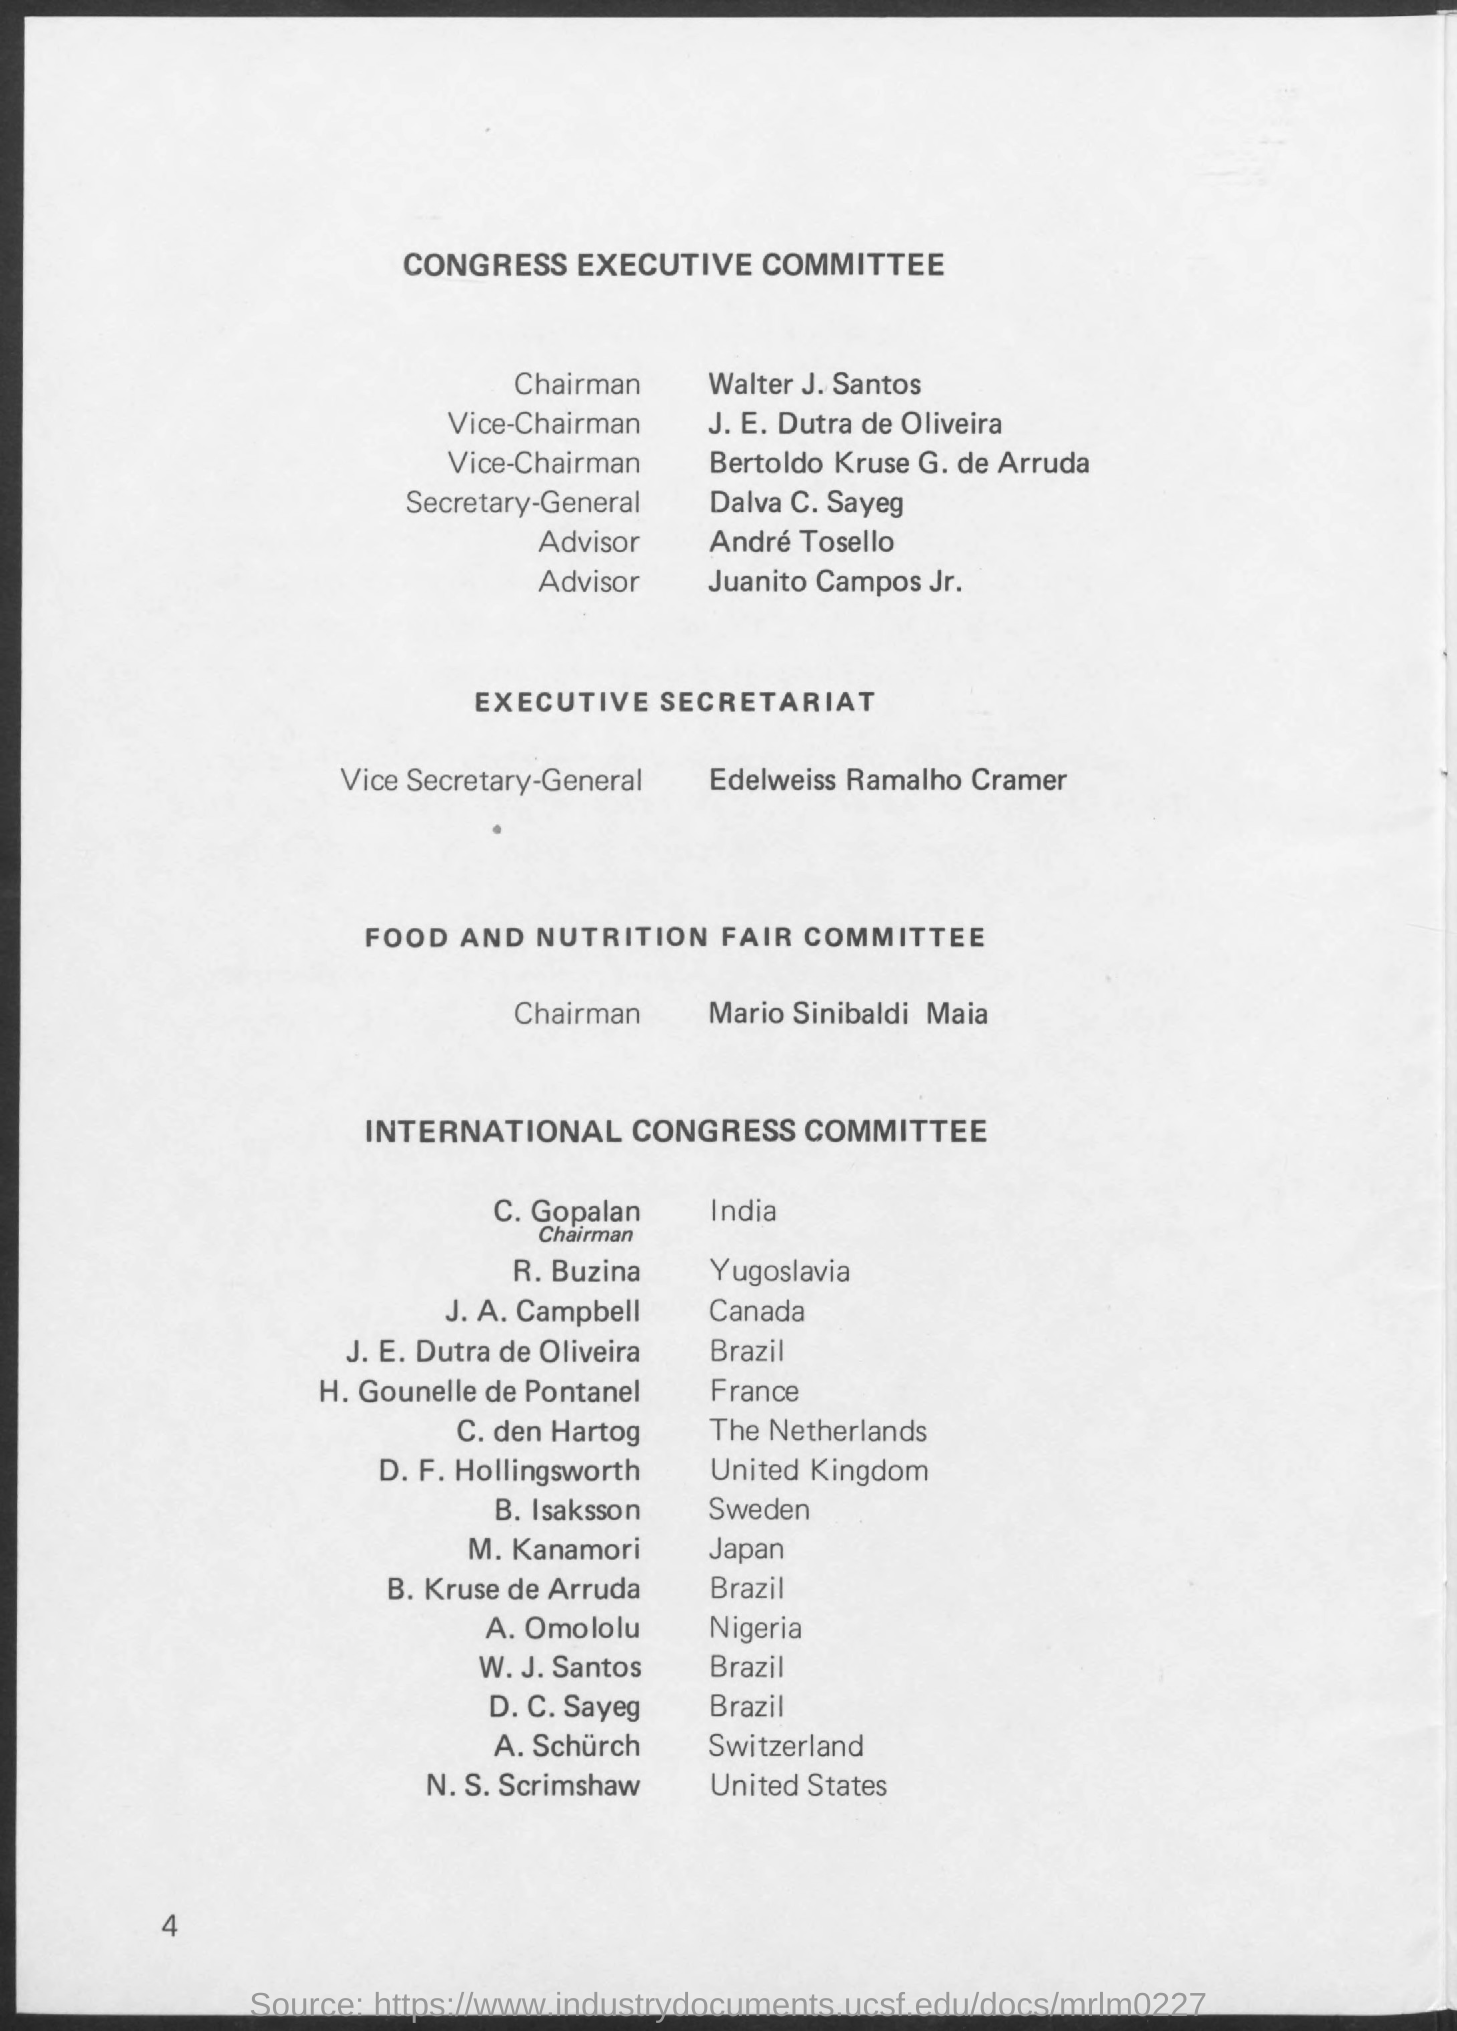Specify some key components in this picture. The International Congress Committee for Japan is composed of M. Kanamori. The International Congress Committee for India is comprised of C. Gopalan. The Secretary-General of the Congress executive committee is Dalva C. Sayeg. The International Congress Committee for Yugoslavia is comprised of R. Buzina. The International Congress Committee for Canada is comprised of J. A. Campbell. 